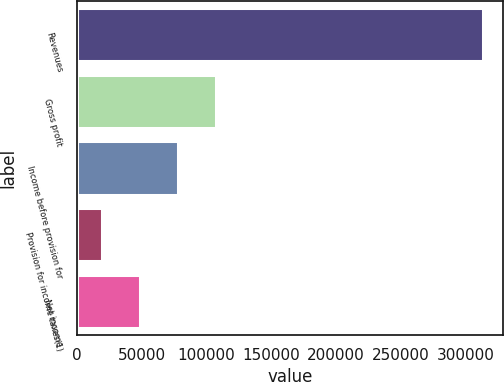Convert chart. <chart><loc_0><loc_0><loc_500><loc_500><bar_chart><fcel>Revenues<fcel>Gross profit<fcel>Income before provision for<fcel>Provision for income taxes(1)<fcel>Net income<nl><fcel>313059<fcel>107644<fcel>78299<fcel>19609<fcel>48954<nl></chart> 